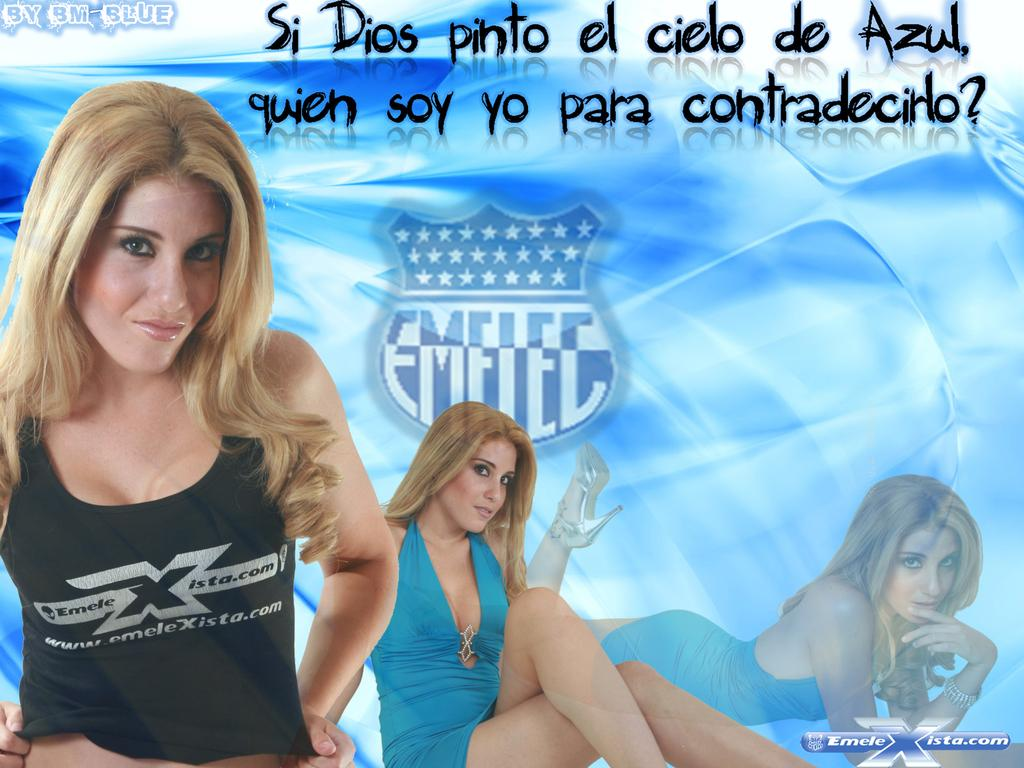What type of content is the image promoting? The image is an advertisement. What visual elements can be seen in the image? There are logos in the image. What type of information is included in the image? There is text in the image. Can you see a mountain in the background of the image? There is no mountain visible in the image. Are there any beads featured in the image? There are no beads present in the image. 